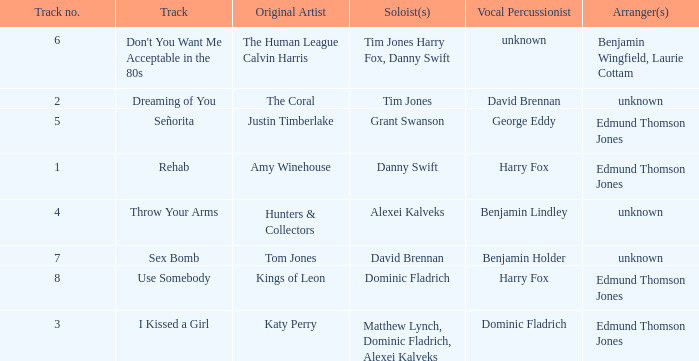Parse the full table. {'header': ['Track no.', 'Track', 'Original Artist', 'Soloist(s)', 'Vocal Percussionist', 'Arranger(s)'], 'rows': [['6', "Don't You Want Me Acceptable in the 80s", 'The Human League Calvin Harris', 'Tim Jones Harry Fox, Danny Swift', 'unknown', 'Benjamin Wingfield, Laurie Cottam'], ['2', 'Dreaming of You', 'The Coral', 'Tim Jones', 'David Brennan', 'unknown'], ['5', 'Señorita', 'Justin Timberlake', 'Grant Swanson', 'George Eddy', 'Edmund Thomson Jones'], ['1', 'Rehab', 'Amy Winehouse', 'Danny Swift', 'Harry Fox', 'Edmund Thomson Jones'], ['4', 'Throw Your Arms', 'Hunters & Collectors', 'Alexei Kalveks', 'Benjamin Lindley', 'unknown'], ['7', 'Sex Bomb', 'Tom Jones', 'David Brennan', 'Benjamin Holder', 'unknown'], ['8', 'Use Somebody', 'Kings of Leon', 'Dominic Fladrich', 'Harry Fox', 'Edmund Thomson Jones'], ['3', 'I Kissed a Girl', 'Katy Perry', 'Matthew Lynch, Dominic Fladrich, Alexei Kalveks', 'Dominic Fladrich', 'Edmund Thomson Jones']]} Who is the percussionist for The Coral? David Brennan. 